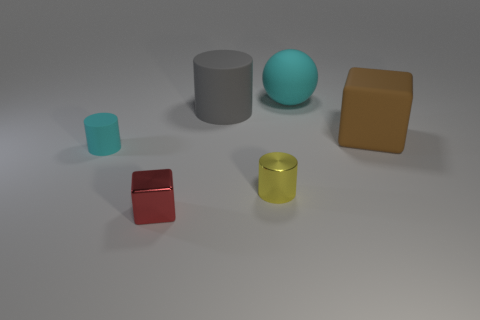Are there any cyan matte objects in front of the big cyan object?
Make the answer very short. Yes. How many red metallic blocks are on the left side of the rubber object in front of the large matte block?
Keep it short and to the point. 0. There is a gray cylinder that is the same size as the brown object; what is it made of?
Make the answer very short. Rubber. What number of other objects are the same material as the large gray cylinder?
Make the answer very short. 3. There is a big gray cylinder; how many large gray matte things are behind it?
Your response must be concise. 0. How many cylinders are large objects or small rubber things?
Provide a short and direct response. 2. There is a matte thing that is on the right side of the gray rubber cylinder and in front of the big cyan ball; what is its size?
Give a very brief answer. Large. What number of other objects are there of the same color as the ball?
Provide a succinct answer. 1. Does the big brown block have the same material as the cylinder that is in front of the tiny cyan object?
Your answer should be very brief. No. How many things are either cylinders on the left side of the gray object or matte balls?
Ensure brevity in your answer.  2. 